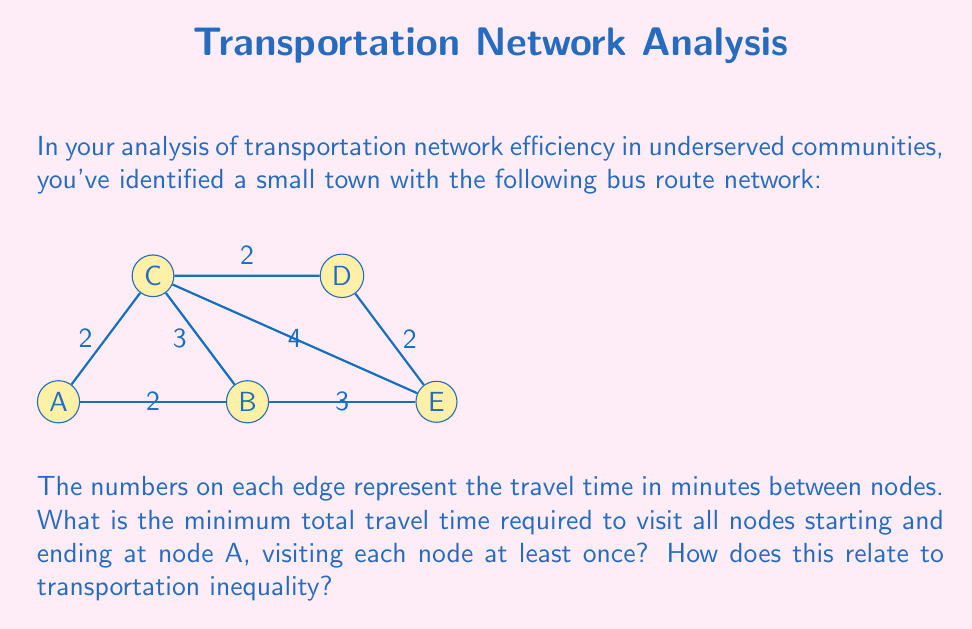Could you help me with this problem? To solve this problem, we need to find the shortest path that visits all nodes starting and ending at A. This is known as the Traveling Salesman Problem (TSP). For small networks like this, we can solve it by considering all possible routes:

1) First, let's list all possible routes:
   A-B-C-D-E-A
   A-B-E-D-C-A
   A-C-B-E-D-A
   A-C-D-E-B-A
   A-E-D-C-B-A

2) Now, let's calculate the total time for each route:
   A-B-C-D-E-A: 2 + 3 + 2 + 2 + 3 = 12 minutes
   A-B-E-D-C-A: 2 + 3 + 2 + 2 + 2 = 11 minutes
   A-C-B-E-D-A: 2 + 3 + 3 + 2 + 2 = 12 minutes
   A-C-D-E-B-A: 2 + 2 + 2 + 3 + 2 = 11 minutes
   A-E-D-C-B-A: 4 + 2 + 2 + 3 + 2 = 13 minutes

3) The minimum total travel time is 11 minutes, achieved by two routes:
   A-B-E-D-C-A or A-C-D-E-B-A

This relates to transportation inequality in several ways:

1) Limited route options: The fact that there are only two optimal routes highlights the lack of flexibility in the network, which is common in underserved communities.

2) Inefficient coverage: The minimum time to cover all nodes is relatively high compared to the individual edge times, indicating that the network is not optimally designed for comprehensive coverage.

3) Potential for improvement: Identifying the optimal route can help planners improve service by focusing on the most efficient paths, potentially leading to more frequent service on these routes.

4) Access disparities: If certain nodes (e.g., E) are less connected, residents near these locations may face longer travel times to reach other parts of the community, exacerbating social inequalities.

5) Resource allocation: Understanding the most efficient routes can guide decisions on where to allocate resources for network improvements, potentially addressing transportation inequalities.
Answer: 11 minutes 